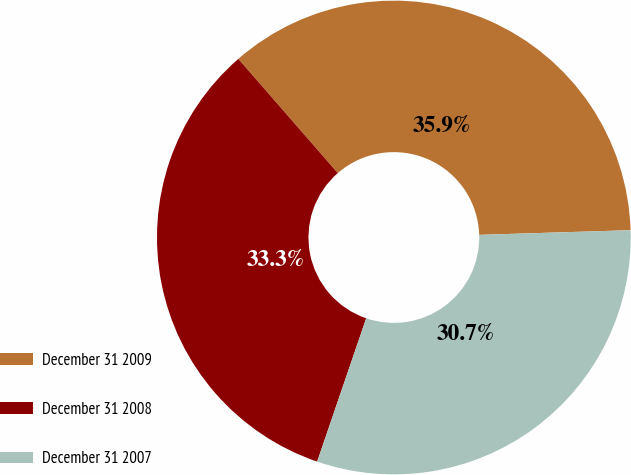Convert chart to OTSL. <chart><loc_0><loc_0><loc_500><loc_500><pie_chart><fcel>December 31 2009<fcel>December 31 2008<fcel>December 31 2007<nl><fcel>35.91%<fcel>33.35%<fcel>30.74%<nl></chart> 